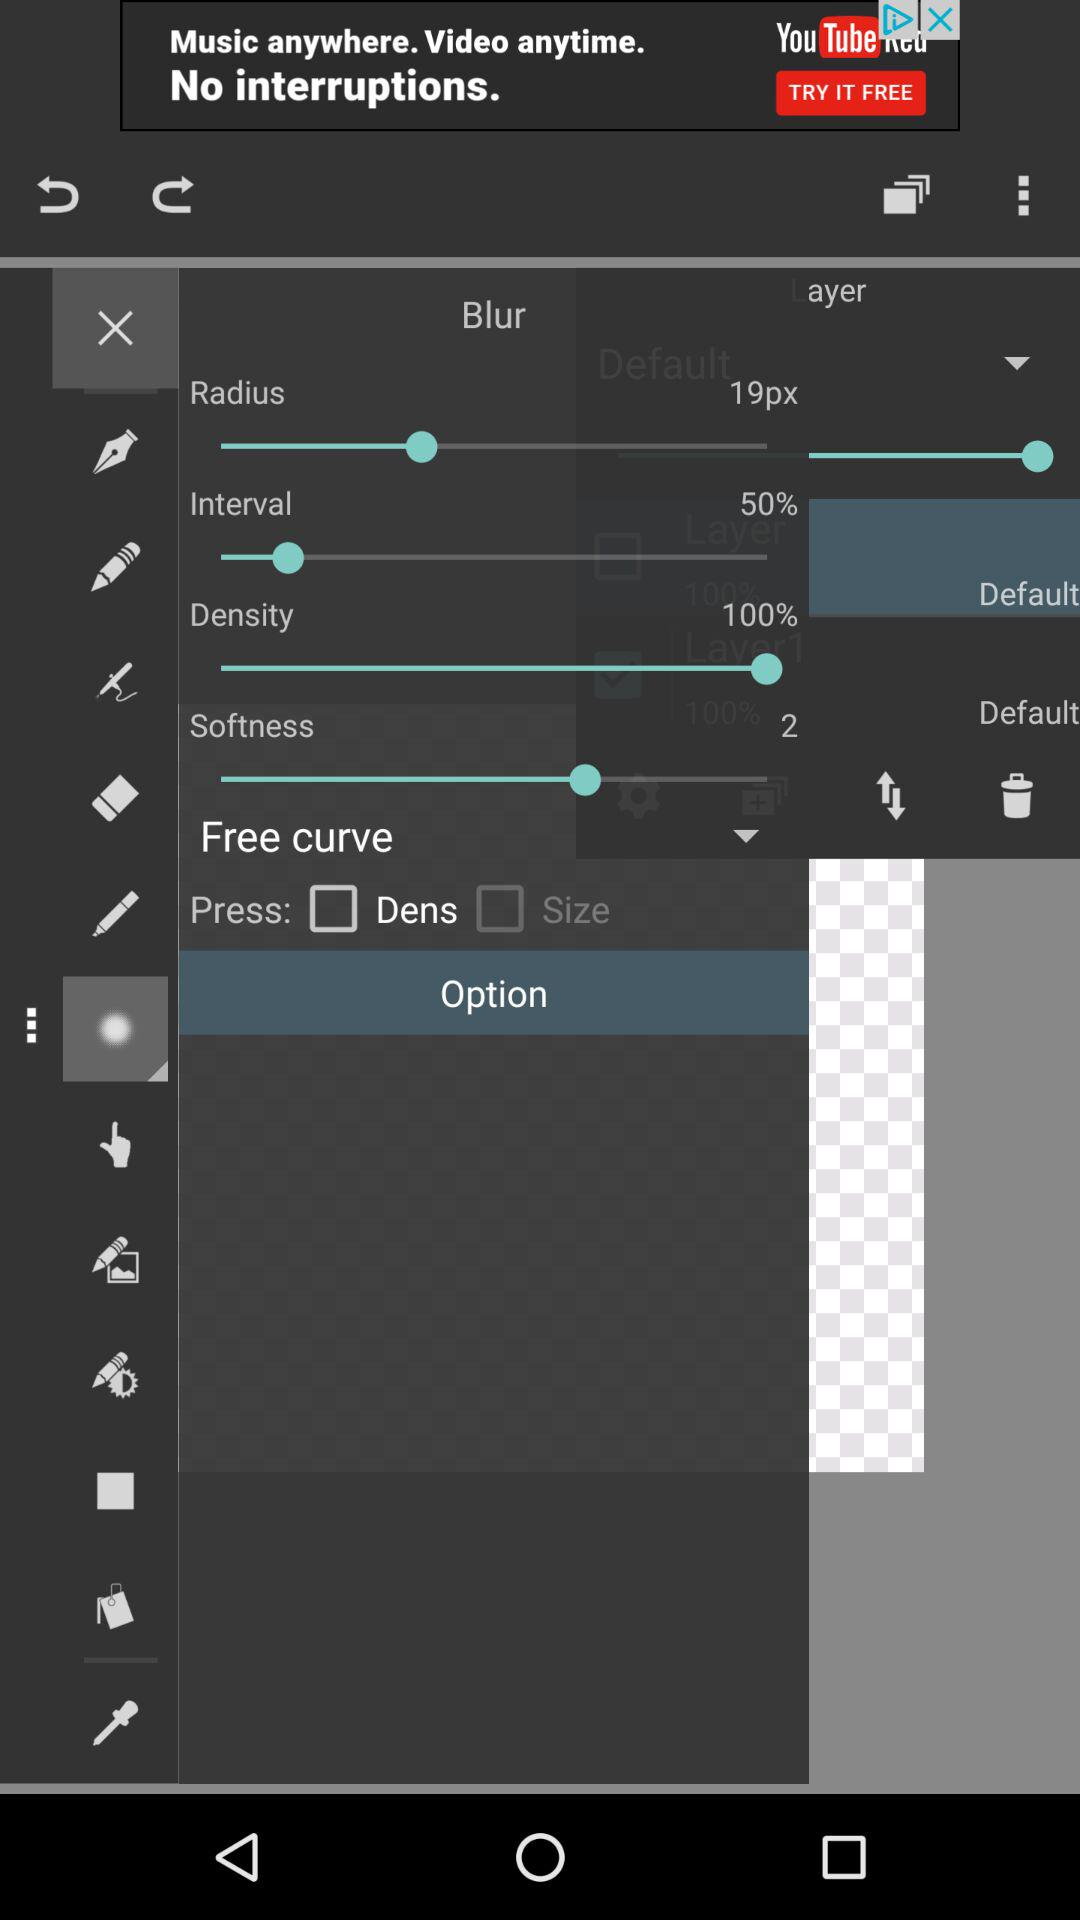What is the setting for density? The density is set to 100%. 